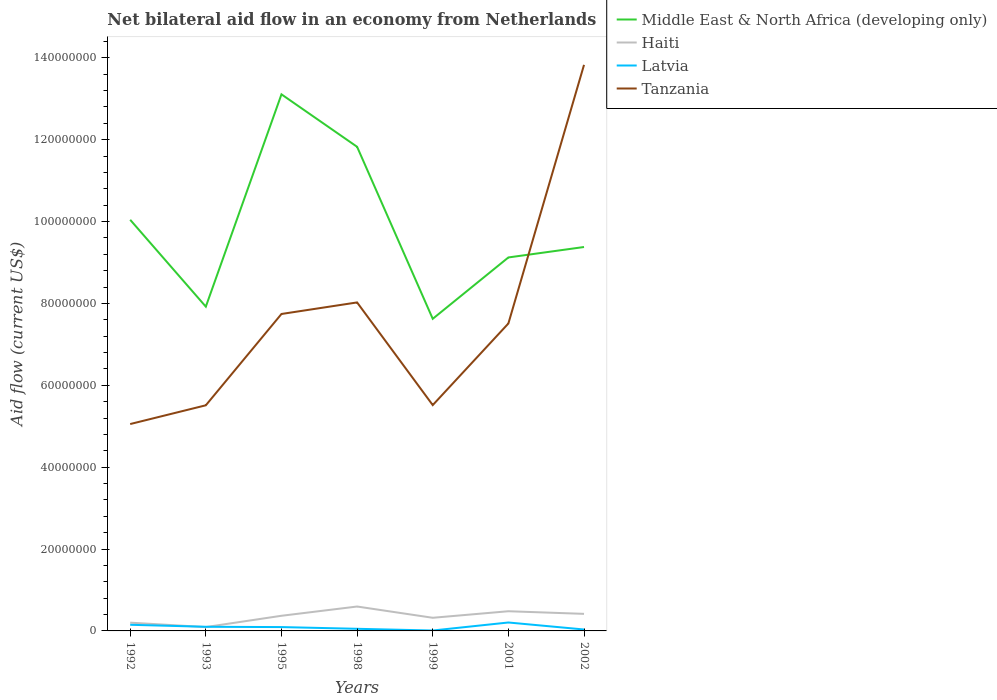How many different coloured lines are there?
Your answer should be very brief. 4. Does the line corresponding to Haiti intersect with the line corresponding to Middle East & North Africa (developing only)?
Offer a terse response. No. What is the total net bilateral aid flow in Haiti in the graph?
Provide a succinct answer. 1.08e+06. What is the difference between the highest and the second highest net bilateral aid flow in Haiti?
Keep it short and to the point. 5.02e+06. How many years are there in the graph?
Offer a very short reply. 7. Does the graph contain grids?
Your answer should be compact. No. Where does the legend appear in the graph?
Give a very brief answer. Top right. How many legend labels are there?
Offer a very short reply. 4. What is the title of the graph?
Offer a terse response. Net bilateral aid flow in an economy from Netherlands. Does "Latin America(all income levels)" appear as one of the legend labels in the graph?
Your answer should be compact. No. What is the Aid flow (current US$) of Middle East & North Africa (developing only) in 1992?
Your answer should be compact. 1.00e+08. What is the Aid flow (current US$) in Haiti in 1992?
Give a very brief answer. 2.02e+06. What is the Aid flow (current US$) in Latvia in 1992?
Keep it short and to the point. 1.50e+06. What is the Aid flow (current US$) of Tanzania in 1992?
Offer a terse response. 5.05e+07. What is the Aid flow (current US$) of Middle East & North Africa (developing only) in 1993?
Keep it short and to the point. 7.92e+07. What is the Aid flow (current US$) in Haiti in 1993?
Offer a terse response. 9.40e+05. What is the Aid flow (current US$) of Latvia in 1993?
Ensure brevity in your answer.  1.01e+06. What is the Aid flow (current US$) in Tanzania in 1993?
Make the answer very short. 5.51e+07. What is the Aid flow (current US$) of Middle East & North Africa (developing only) in 1995?
Give a very brief answer. 1.31e+08. What is the Aid flow (current US$) of Haiti in 1995?
Offer a very short reply. 3.70e+06. What is the Aid flow (current US$) of Latvia in 1995?
Offer a very short reply. 9.40e+05. What is the Aid flow (current US$) of Tanzania in 1995?
Offer a very short reply. 7.74e+07. What is the Aid flow (current US$) in Middle East & North Africa (developing only) in 1998?
Offer a very short reply. 1.18e+08. What is the Aid flow (current US$) in Haiti in 1998?
Offer a very short reply. 5.96e+06. What is the Aid flow (current US$) of Latvia in 1998?
Your answer should be very brief. 5.20e+05. What is the Aid flow (current US$) in Tanzania in 1998?
Provide a short and direct response. 8.02e+07. What is the Aid flow (current US$) in Middle East & North Africa (developing only) in 1999?
Offer a terse response. 7.62e+07. What is the Aid flow (current US$) in Haiti in 1999?
Ensure brevity in your answer.  3.21e+06. What is the Aid flow (current US$) of Tanzania in 1999?
Your response must be concise. 5.52e+07. What is the Aid flow (current US$) of Middle East & North Africa (developing only) in 2001?
Provide a succinct answer. 9.12e+07. What is the Aid flow (current US$) of Haiti in 2001?
Give a very brief answer. 4.81e+06. What is the Aid flow (current US$) of Latvia in 2001?
Your answer should be very brief. 2.06e+06. What is the Aid flow (current US$) of Tanzania in 2001?
Your answer should be compact. 7.51e+07. What is the Aid flow (current US$) of Middle East & North Africa (developing only) in 2002?
Make the answer very short. 9.38e+07. What is the Aid flow (current US$) of Haiti in 2002?
Offer a terse response. 4.17e+06. What is the Aid flow (current US$) of Latvia in 2002?
Keep it short and to the point. 3.50e+05. What is the Aid flow (current US$) of Tanzania in 2002?
Give a very brief answer. 1.38e+08. Across all years, what is the maximum Aid flow (current US$) of Middle East & North Africa (developing only)?
Your answer should be compact. 1.31e+08. Across all years, what is the maximum Aid flow (current US$) in Haiti?
Your answer should be very brief. 5.96e+06. Across all years, what is the maximum Aid flow (current US$) of Latvia?
Your answer should be compact. 2.06e+06. Across all years, what is the maximum Aid flow (current US$) of Tanzania?
Your answer should be compact. 1.38e+08. Across all years, what is the minimum Aid flow (current US$) of Middle East & North Africa (developing only)?
Ensure brevity in your answer.  7.62e+07. Across all years, what is the minimum Aid flow (current US$) in Haiti?
Your response must be concise. 9.40e+05. Across all years, what is the minimum Aid flow (current US$) in Tanzania?
Provide a short and direct response. 5.05e+07. What is the total Aid flow (current US$) in Middle East & North Africa (developing only) in the graph?
Keep it short and to the point. 6.90e+08. What is the total Aid flow (current US$) in Haiti in the graph?
Your response must be concise. 2.48e+07. What is the total Aid flow (current US$) in Latvia in the graph?
Ensure brevity in your answer.  6.48e+06. What is the total Aid flow (current US$) in Tanzania in the graph?
Offer a terse response. 5.32e+08. What is the difference between the Aid flow (current US$) of Middle East & North Africa (developing only) in 1992 and that in 1993?
Ensure brevity in your answer.  2.12e+07. What is the difference between the Aid flow (current US$) of Haiti in 1992 and that in 1993?
Provide a short and direct response. 1.08e+06. What is the difference between the Aid flow (current US$) in Tanzania in 1992 and that in 1993?
Provide a succinct answer. -4.58e+06. What is the difference between the Aid flow (current US$) in Middle East & North Africa (developing only) in 1992 and that in 1995?
Your answer should be very brief. -3.06e+07. What is the difference between the Aid flow (current US$) of Haiti in 1992 and that in 1995?
Give a very brief answer. -1.68e+06. What is the difference between the Aid flow (current US$) in Latvia in 1992 and that in 1995?
Provide a succinct answer. 5.60e+05. What is the difference between the Aid flow (current US$) in Tanzania in 1992 and that in 1995?
Your answer should be very brief. -2.69e+07. What is the difference between the Aid flow (current US$) in Middle East & North Africa (developing only) in 1992 and that in 1998?
Offer a terse response. -1.78e+07. What is the difference between the Aid flow (current US$) of Haiti in 1992 and that in 1998?
Offer a very short reply. -3.94e+06. What is the difference between the Aid flow (current US$) of Latvia in 1992 and that in 1998?
Your response must be concise. 9.80e+05. What is the difference between the Aid flow (current US$) in Tanzania in 1992 and that in 1998?
Your response must be concise. -2.97e+07. What is the difference between the Aid flow (current US$) in Middle East & North Africa (developing only) in 1992 and that in 1999?
Your answer should be compact. 2.42e+07. What is the difference between the Aid flow (current US$) of Haiti in 1992 and that in 1999?
Provide a short and direct response. -1.19e+06. What is the difference between the Aid flow (current US$) in Latvia in 1992 and that in 1999?
Provide a short and direct response. 1.40e+06. What is the difference between the Aid flow (current US$) of Tanzania in 1992 and that in 1999?
Your response must be concise. -4.63e+06. What is the difference between the Aid flow (current US$) of Middle East & North Africa (developing only) in 1992 and that in 2001?
Your answer should be compact. 9.20e+06. What is the difference between the Aid flow (current US$) in Haiti in 1992 and that in 2001?
Keep it short and to the point. -2.79e+06. What is the difference between the Aid flow (current US$) of Latvia in 1992 and that in 2001?
Keep it short and to the point. -5.60e+05. What is the difference between the Aid flow (current US$) in Tanzania in 1992 and that in 2001?
Ensure brevity in your answer.  -2.46e+07. What is the difference between the Aid flow (current US$) in Middle East & North Africa (developing only) in 1992 and that in 2002?
Give a very brief answer. 6.65e+06. What is the difference between the Aid flow (current US$) in Haiti in 1992 and that in 2002?
Give a very brief answer. -2.15e+06. What is the difference between the Aid flow (current US$) of Latvia in 1992 and that in 2002?
Make the answer very short. 1.15e+06. What is the difference between the Aid flow (current US$) in Tanzania in 1992 and that in 2002?
Give a very brief answer. -8.78e+07. What is the difference between the Aid flow (current US$) of Middle East & North Africa (developing only) in 1993 and that in 1995?
Provide a short and direct response. -5.19e+07. What is the difference between the Aid flow (current US$) in Haiti in 1993 and that in 1995?
Your response must be concise. -2.76e+06. What is the difference between the Aid flow (current US$) in Tanzania in 1993 and that in 1995?
Your answer should be compact. -2.23e+07. What is the difference between the Aid flow (current US$) of Middle East & North Africa (developing only) in 1993 and that in 1998?
Provide a short and direct response. -3.90e+07. What is the difference between the Aid flow (current US$) of Haiti in 1993 and that in 1998?
Your response must be concise. -5.02e+06. What is the difference between the Aid flow (current US$) of Tanzania in 1993 and that in 1998?
Offer a very short reply. -2.51e+07. What is the difference between the Aid flow (current US$) in Middle East & North Africa (developing only) in 1993 and that in 1999?
Make the answer very short. 2.97e+06. What is the difference between the Aid flow (current US$) in Haiti in 1993 and that in 1999?
Offer a very short reply. -2.27e+06. What is the difference between the Aid flow (current US$) of Latvia in 1993 and that in 1999?
Provide a short and direct response. 9.10e+05. What is the difference between the Aid flow (current US$) of Middle East & North Africa (developing only) in 1993 and that in 2001?
Keep it short and to the point. -1.20e+07. What is the difference between the Aid flow (current US$) of Haiti in 1993 and that in 2001?
Your answer should be very brief. -3.87e+06. What is the difference between the Aid flow (current US$) of Latvia in 1993 and that in 2001?
Give a very brief answer. -1.05e+06. What is the difference between the Aid flow (current US$) of Tanzania in 1993 and that in 2001?
Ensure brevity in your answer.  -2.00e+07. What is the difference between the Aid flow (current US$) in Middle East & North Africa (developing only) in 1993 and that in 2002?
Your response must be concise. -1.46e+07. What is the difference between the Aid flow (current US$) of Haiti in 1993 and that in 2002?
Give a very brief answer. -3.23e+06. What is the difference between the Aid flow (current US$) of Latvia in 1993 and that in 2002?
Your answer should be very brief. 6.60e+05. What is the difference between the Aid flow (current US$) in Tanzania in 1993 and that in 2002?
Offer a terse response. -8.32e+07. What is the difference between the Aid flow (current US$) in Middle East & North Africa (developing only) in 1995 and that in 1998?
Offer a very short reply. 1.28e+07. What is the difference between the Aid flow (current US$) of Haiti in 1995 and that in 1998?
Your answer should be compact. -2.26e+06. What is the difference between the Aid flow (current US$) of Tanzania in 1995 and that in 1998?
Ensure brevity in your answer.  -2.82e+06. What is the difference between the Aid flow (current US$) in Middle East & North Africa (developing only) in 1995 and that in 1999?
Ensure brevity in your answer.  5.48e+07. What is the difference between the Aid flow (current US$) of Haiti in 1995 and that in 1999?
Your answer should be compact. 4.90e+05. What is the difference between the Aid flow (current US$) of Latvia in 1995 and that in 1999?
Give a very brief answer. 8.40e+05. What is the difference between the Aid flow (current US$) of Tanzania in 1995 and that in 1999?
Provide a short and direct response. 2.23e+07. What is the difference between the Aid flow (current US$) of Middle East & North Africa (developing only) in 1995 and that in 2001?
Provide a short and direct response. 3.98e+07. What is the difference between the Aid flow (current US$) in Haiti in 1995 and that in 2001?
Give a very brief answer. -1.11e+06. What is the difference between the Aid flow (current US$) of Latvia in 1995 and that in 2001?
Your answer should be compact. -1.12e+06. What is the difference between the Aid flow (current US$) in Tanzania in 1995 and that in 2001?
Make the answer very short. 2.32e+06. What is the difference between the Aid flow (current US$) in Middle East & North Africa (developing only) in 1995 and that in 2002?
Offer a very short reply. 3.73e+07. What is the difference between the Aid flow (current US$) in Haiti in 1995 and that in 2002?
Keep it short and to the point. -4.70e+05. What is the difference between the Aid flow (current US$) in Latvia in 1995 and that in 2002?
Keep it short and to the point. 5.90e+05. What is the difference between the Aid flow (current US$) of Tanzania in 1995 and that in 2002?
Keep it short and to the point. -6.09e+07. What is the difference between the Aid flow (current US$) of Middle East & North Africa (developing only) in 1998 and that in 1999?
Give a very brief answer. 4.20e+07. What is the difference between the Aid flow (current US$) in Haiti in 1998 and that in 1999?
Ensure brevity in your answer.  2.75e+06. What is the difference between the Aid flow (current US$) of Latvia in 1998 and that in 1999?
Provide a short and direct response. 4.20e+05. What is the difference between the Aid flow (current US$) in Tanzania in 1998 and that in 1999?
Give a very brief answer. 2.51e+07. What is the difference between the Aid flow (current US$) of Middle East & North Africa (developing only) in 1998 and that in 2001?
Your answer should be compact. 2.70e+07. What is the difference between the Aid flow (current US$) of Haiti in 1998 and that in 2001?
Provide a succinct answer. 1.15e+06. What is the difference between the Aid flow (current US$) of Latvia in 1998 and that in 2001?
Offer a terse response. -1.54e+06. What is the difference between the Aid flow (current US$) of Tanzania in 1998 and that in 2001?
Provide a short and direct response. 5.14e+06. What is the difference between the Aid flow (current US$) in Middle East & North Africa (developing only) in 1998 and that in 2002?
Your answer should be very brief. 2.45e+07. What is the difference between the Aid flow (current US$) in Haiti in 1998 and that in 2002?
Offer a terse response. 1.79e+06. What is the difference between the Aid flow (current US$) of Latvia in 1998 and that in 2002?
Ensure brevity in your answer.  1.70e+05. What is the difference between the Aid flow (current US$) of Tanzania in 1998 and that in 2002?
Provide a succinct answer. -5.80e+07. What is the difference between the Aid flow (current US$) in Middle East & North Africa (developing only) in 1999 and that in 2001?
Give a very brief answer. -1.50e+07. What is the difference between the Aid flow (current US$) in Haiti in 1999 and that in 2001?
Your answer should be compact. -1.60e+06. What is the difference between the Aid flow (current US$) of Latvia in 1999 and that in 2001?
Offer a terse response. -1.96e+06. What is the difference between the Aid flow (current US$) in Tanzania in 1999 and that in 2001?
Provide a succinct answer. -1.99e+07. What is the difference between the Aid flow (current US$) of Middle East & North Africa (developing only) in 1999 and that in 2002?
Your answer should be compact. -1.75e+07. What is the difference between the Aid flow (current US$) of Haiti in 1999 and that in 2002?
Give a very brief answer. -9.60e+05. What is the difference between the Aid flow (current US$) of Latvia in 1999 and that in 2002?
Offer a very short reply. -2.50e+05. What is the difference between the Aid flow (current US$) in Tanzania in 1999 and that in 2002?
Keep it short and to the point. -8.31e+07. What is the difference between the Aid flow (current US$) of Middle East & North Africa (developing only) in 2001 and that in 2002?
Keep it short and to the point. -2.55e+06. What is the difference between the Aid flow (current US$) in Haiti in 2001 and that in 2002?
Keep it short and to the point. 6.40e+05. What is the difference between the Aid flow (current US$) in Latvia in 2001 and that in 2002?
Offer a terse response. 1.71e+06. What is the difference between the Aid flow (current US$) of Tanzania in 2001 and that in 2002?
Your answer should be very brief. -6.32e+07. What is the difference between the Aid flow (current US$) in Middle East & North Africa (developing only) in 1992 and the Aid flow (current US$) in Haiti in 1993?
Offer a very short reply. 9.95e+07. What is the difference between the Aid flow (current US$) of Middle East & North Africa (developing only) in 1992 and the Aid flow (current US$) of Latvia in 1993?
Your answer should be very brief. 9.94e+07. What is the difference between the Aid flow (current US$) of Middle East & North Africa (developing only) in 1992 and the Aid flow (current US$) of Tanzania in 1993?
Offer a terse response. 4.53e+07. What is the difference between the Aid flow (current US$) in Haiti in 1992 and the Aid flow (current US$) in Latvia in 1993?
Provide a succinct answer. 1.01e+06. What is the difference between the Aid flow (current US$) of Haiti in 1992 and the Aid flow (current US$) of Tanzania in 1993?
Keep it short and to the point. -5.31e+07. What is the difference between the Aid flow (current US$) of Latvia in 1992 and the Aid flow (current US$) of Tanzania in 1993?
Offer a very short reply. -5.36e+07. What is the difference between the Aid flow (current US$) in Middle East & North Africa (developing only) in 1992 and the Aid flow (current US$) in Haiti in 1995?
Provide a short and direct response. 9.67e+07. What is the difference between the Aid flow (current US$) in Middle East & North Africa (developing only) in 1992 and the Aid flow (current US$) in Latvia in 1995?
Your answer should be compact. 9.95e+07. What is the difference between the Aid flow (current US$) of Middle East & North Africa (developing only) in 1992 and the Aid flow (current US$) of Tanzania in 1995?
Your answer should be very brief. 2.30e+07. What is the difference between the Aid flow (current US$) in Haiti in 1992 and the Aid flow (current US$) in Latvia in 1995?
Your answer should be very brief. 1.08e+06. What is the difference between the Aid flow (current US$) of Haiti in 1992 and the Aid flow (current US$) of Tanzania in 1995?
Your response must be concise. -7.54e+07. What is the difference between the Aid flow (current US$) in Latvia in 1992 and the Aid flow (current US$) in Tanzania in 1995?
Give a very brief answer. -7.59e+07. What is the difference between the Aid flow (current US$) in Middle East & North Africa (developing only) in 1992 and the Aid flow (current US$) in Haiti in 1998?
Your answer should be compact. 9.45e+07. What is the difference between the Aid flow (current US$) in Middle East & North Africa (developing only) in 1992 and the Aid flow (current US$) in Latvia in 1998?
Your answer should be compact. 9.99e+07. What is the difference between the Aid flow (current US$) in Middle East & North Africa (developing only) in 1992 and the Aid flow (current US$) in Tanzania in 1998?
Offer a terse response. 2.02e+07. What is the difference between the Aid flow (current US$) of Haiti in 1992 and the Aid flow (current US$) of Latvia in 1998?
Keep it short and to the point. 1.50e+06. What is the difference between the Aid flow (current US$) in Haiti in 1992 and the Aid flow (current US$) in Tanzania in 1998?
Provide a succinct answer. -7.82e+07. What is the difference between the Aid flow (current US$) of Latvia in 1992 and the Aid flow (current US$) of Tanzania in 1998?
Provide a succinct answer. -7.88e+07. What is the difference between the Aid flow (current US$) of Middle East & North Africa (developing only) in 1992 and the Aid flow (current US$) of Haiti in 1999?
Provide a short and direct response. 9.72e+07. What is the difference between the Aid flow (current US$) in Middle East & North Africa (developing only) in 1992 and the Aid flow (current US$) in Latvia in 1999?
Your answer should be very brief. 1.00e+08. What is the difference between the Aid flow (current US$) in Middle East & North Africa (developing only) in 1992 and the Aid flow (current US$) in Tanzania in 1999?
Provide a short and direct response. 4.53e+07. What is the difference between the Aid flow (current US$) of Haiti in 1992 and the Aid flow (current US$) of Latvia in 1999?
Your answer should be compact. 1.92e+06. What is the difference between the Aid flow (current US$) in Haiti in 1992 and the Aid flow (current US$) in Tanzania in 1999?
Keep it short and to the point. -5.32e+07. What is the difference between the Aid flow (current US$) of Latvia in 1992 and the Aid flow (current US$) of Tanzania in 1999?
Your answer should be very brief. -5.37e+07. What is the difference between the Aid flow (current US$) of Middle East & North Africa (developing only) in 1992 and the Aid flow (current US$) of Haiti in 2001?
Give a very brief answer. 9.56e+07. What is the difference between the Aid flow (current US$) in Middle East & North Africa (developing only) in 1992 and the Aid flow (current US$) in Latvia in 2001?
Offer a very short reply. 9.84e+07. What is the difference between the Aid flow (current US$) of Middle East & North Africa (developing only) in 1992 and the Aid flow (current US$) of Tanzania in 2001?
Offer a terse response. 2.53e+07. What is the difference between the Aid flow (current US$) of Haiti in 1992 and the Aid flow (current US$) of Latvia in 2001?
Give a very brief answer. -4.00e+04. What is the difference between the Aid flow (current US$) of Haiti in 1992 and the Aid flow (current US$) of Tanzania in 2001?
Give a very brief answer. -7.31e+07. What is the difference between the Aid flow (current US$) in Latvia in 1992 and the Aid flow (current US$) in Tanzania in 2001?
Provide a succinct answer. -7.36e+07. What is the difference between the Aid flow (current US$) of Middle East & North Africa (developing only) in 1992 and the Aid flow (current US$) of Haiti in 2002?
Provide a succinct answer. 9.63e+07. What is the difference between the Aid flow (current US$) in Middle East & North Africa (developing only) in 1992 and the Aid flow (current US$) in Latvia in 2002?
Your answer should be compact. 1.00e+08. What is the difference between the Aid flow (current US$) of Middle East & North Africa (developing only) in 1992 and the Aid flow (current US$) of Tanzania in 2002?
Ensure brevity in your answer.  -3.78e+07. What is the difference between the Aid flow (current US$) in Haiti in 1992 and the Aid flow (current US$) in Latvia in 2002?
Offer a very short reply. 1.67e+06. What is the difference between the Aid flow (current US$) of Haiti in 1992 and the Aid flow (current US$) of Tanzania in 2002?
Give a very brief answer. -1.36e+08. What is the difference between the Aid flow (current US$) of Latvia in 1992 and the Aid flow (current US$) of Tanzania in 2002?
Your answer should be compact. -1.37e+08. What is the difference between the Aid flow (current US$) in Middle East & North Africa (developing only) in 1993 and the Aid flow (current US$) in Haiti in 1995?
Give a very brief answer. 7.55e+07. What is the difference between the Aid flow (current US$) in Middle East & North Africa (developing only) in 1993 and the Aid flow (current US$) in Latvia in 1995?
Offer a terse response. 7.83e+07. What is the difference between the Aid flow (current US$) in Middle East & North Africa (developing only) in 1993 and the Aid flow (current US$) in Tanzania in 1995?
Offer a terse response. 1.79e+06. What is the difference between the Aid flow (current US$) in Haiti in 1993 and the Aid flow (current US$) in Latvia in 1995?
Your response must be concise. 0. What is the difference between the Aid flow (current US$) in Haiti in 1993 and the Aid flow (current US$) in Tanzania in 1995?
Offer a terse response. -7.65e+07. What is the difference between the Aid flow (current US$) of Latvia in 1993 and the Aid flow (current US$) of Tanzania in 1995?
Your response must be concise. -7.64e+07. What is the difference between the Aid flow (current US$) of Middle East & North Africa (developing only) in 1993 and the Aid flow (current US$) of Haiti in 1998?
Provide a short and direct response. 7.33e+07. What is the difference between the Aid flow (current US$) in Middle East & North Africa (developing only) in 1993 and the Aid flow (current US$) in Latvia in 1998?
Make the answer very short. 7.87e+07. What is the difference between the Aid flow (current US$) in Middle East & North Africa (developing only) in 1993 and the Aid flow (current US$) in Tanzania in 1998?
Your answer should be very brief. -1.03e+06. What is the difference between the Aid flow (current US$) in Haiti in 1993 and the Aid flow (current US$) in Tanzania in 1998?
Give a very brief answer. -7.93e+07. What is the difference between the Aid flow (current US$) in Latvia in 1993 and the Aid flow (current US$) in Tanzania in 1998?
Give a very brief answer. -7.92e+07. What is the difference between the Aid flow (current US$) in Middle East & North Africa (developing only) in 1993 and the Aid flow (current US$) in Haiti in 1999?
Offer a very short reply. 7.60e+07. What is the difference between the Aid flow (current US$) of Middle East & North Africa (developing only) in 1993 and the Aid flow (current US$) of Latvia in 1999?
Offer a very short reply. 7.91e+07. What is the difference between the Aid flow (current US$) of Middle East & North Africa (developing only) in 1993 and the Aid flow (current US$) of Tanzania in 1999?
Offer a very short reply. 2.40e+07. What is the difference between the Aid flow (current US$) in Haiti in 1993 and the Aid flow (current US$) in Latvia in 1999?
Ensure brevity in your answer.  8.40e+05. What is the difference between the Aid flow (current US$) in Haiti in 1993 and the Aid flow (current US$) in Tanzania in 1999?
Provide a short and direct response. -5.42e+07. What is the difference between the Aid flow (current US$) in Latvia in 1993 and the Aid flow (current US$) in Tanzania in 1999?
Offer a very short reply. -5.42e+07. What is the difference between the Aid flow (current US$) of Middle East & North Africa (developing only) in 1993 and the Aid flow (current US$) of Haiti in 2001?
Provide a succinct answer. 7.44e+07. What is the difference between the Aid flow (current US$) of Middle East & North Africa (developing only) in 1993 and the Aid flow (current US$) of Latvia in 2001?
Your response must be concise. 7.72e+07. What is the difference between the Aid flow (current US$) in Middle East & North Africa (developing only) in 1993 and the Aid flow (current US$) in Tanzania in 2001?
Ensure brevity in your answer.  4.11e+06. What is the difference between the Aid flow (current US$) in Haiti in 1993 and the Aid flow (current US$) in Latvia in 2001?
Keep it short and to the point. -1.12e+06. What is the difference between the Aid flow (current US$) of Haiti in 1993 and the Aid flow (current US$) of Tanzania in 2001?
Provide a succinct answer. -7.42e+07. What is the difference between the Aid flow (current US$) of Latvia in 1993 and the Aid flow (current US$) of Tanzania in 2001?
Your answer should be very brief. -7.41e+07. What is the difference between the Aid flow (current US$) in Middle East & North Africa (developing only) in 1993 and the Aid flow (current US$) in Haiti in 2002?
Keep it short and to the point. 7.50e+07. What is the difference between the Aid flow (current US$) in Middle East & North Africa (developing only) in 1993 and the Aid flow (current US$) in Latvia in 2002?
Offer a terse response. 7.89e+07. What is the difference between the Aid flow (current US$) of Middle East & North Africa (developing only) in 1993 and the Aid flow (current US$) of Tanzania in 2002?
Your answer should be compact. -5.91e+07. What is the difference between the Aid flow (current US$) in Haiti in 1993 and the Aid flow (current US$) in Latvia in 2002?
Your response must be concise. 5.90e+05. What is the difference between the Aid flow (current US$) in Haiti in 1993 and the Aid flow (current US$) in Tanzania in 2002?
Give a very brief answer. -1.37e+08. What is the difference between the Aid flow (current US$) in Latvia in 1993 and the Aid flow (current US$) in Tanzania in 2002?
Give a very brief answer. -1.37e+08. What is the difference between the Aid flow (current US$) of Middle East & North Africa (developing only) in 1995 and the Aid flow (current US$) of Haiti in 1998?
Make the answer very short. 1.25e+08. What is the difference between the Aid flow (current US$) in Middle East & North Africa (developing only) in 1995 and the Aid flow (current US$) in Latvia in 1998?
Keep it short and to the point. 1.31e+08. What is the difference between the Aid flow (current US$) of Middle East & North Africa (developing only) in 1995 and the Aid flow (current US$) of Tanzania in 1998?
Provide a short and direct response. 5.08e+07. What is the difference between the Aid flow (current US$) of Haiti in 1995 and the Aid flow (current US$) of Latvia in 1998?
Keep it short and to the point. 3.18e+06. What is the difference between the Aid flow (current US$) in Haiti in 1995 and the Aid flow (current US$) in Tanzania in 1998?
Give a very brief answer. -7.66e+07. What is the difference between the Aid flow (current US$) of Latvia in 1995 and the Aid flow (current US$) of Tanzania in 1998?
Provide a short and direct response. -7.93e+07. What is the difference between the Aid flow (current US$) in Middle East & North Africa (developing only) in 1995 and the Aid flow (current US$) in Haiti in 1999?
Your answer should be very brief. 1.28e+08. What is the difference between the Aid flow (current US$) of Middle East & North Africa (developing only) in 1995 and the Aid flow (current US$) of Latvia in 1999?
Make the answer very short. 1.31e+08. What is the difference between the Aid flow (current US$) in Middle East & North Africa (developing only) in 1995 and the Aid flow (current US$) in Tanzania in 1999?
Ensure brevity in your answer.  7.59e+07. What is the difference between the Aid flow (current US$) in Haiti in 1995 and the Aid flow (current US$) in Latvia in 1999?
Provide a succinct answer. 3.60e+06. What is the difference between the Aid flow (current US$) of Haiti in 1995 and the Aid flow (current US$) of Tanzania in 1999?
Provide a short and direct response. -5.15e+07. What is the difference between the Aid flow (current US$) of Latvia in 1995 and the Aid flow (current US$) of Tanzania in 1999?
Your answer should be very brief. -5.42e+07. What is the difference between the Aid flow (current US$) in Middle East & North Africa (developing only) in 1995 and the Aid flow (current US$) in Haiti in 2001?
Provide a succinct answer. 1.26e+08. What is the difference between the Aid flow (current US$) of Middle East & North Africa (developing only) in 1995 and the Aid flow (current US$) of Latvia in 2001?
Provide a short and direct response. 1.29e+08. What is the difference between the Aid flow (current US$) of Middle East & North Africa (developing only) in 1995 and the Aid flow (current US$) of Tanzania in 2001?
Your response must be concise. 5.60e+07. What is the difference between the Aid flow (current US$) of Haiti in 1995 and the Aid flow (current US$) of Latvia in 2001?
Keep it short and to the point. 1.64e+06. What is the difference between the Aid flow (current US$) of Haiti in 1995 and the Aid flow (current US$) of Tanzania in 2001?
Provide a succinct answer. -7.14e+07. What is the difference between the Aid flow (current US$) of Latvia in 1995 and the Aid flow (current US$) of Tanzania in 2001?
Offer a very short reply. -7.42e+07. What is the difference between the Aid flow (current US$) of Middle East & North Africa (developing only) in 1995 and the Aid flow (current US$) of Haiti in 2002?
Provide a short and direct response. 1.27e+08. What is the difference between the Aid flow (current US$) in Middle East & North Africa (developing only) in 1995 and the Aid flow (current US$) in Latvia in 2002?
Keep it short and to the point. 1.31e+08. What is the difference between the Aid flow (current US$) of Middle East & North Africa (developing only) in 1995 and the Aid flow (current US$) of Tanzania in 2002?
Make the answer very short. -7.20e+06. What is the difference between the Aid flow (current US$) in Haiti in 1995 and the Aid flow (current US$) in Latvia in 2002?
Make the answer very short. 3.35e+06. What is the difference between the Aid flow (current US$) in Haiti in 1995 and the Aid flow (current US$) in Tanzania in 2002?
Provide a short and direct response. -1.35e+08. What is the difference between the Aid flow (current US$) in Latvia in 1995 and the Aid flow (current US$) in Tanzania in 2002?
Offer a very short reply. -1.37e+08. What is the difference between the Aid flow (current US$) of Middle East & North Africa (developing only) in 1998 and the Aid flow (current US$) of Haiti in 1999?
Offer a very short reply. 1.15e+08. What is the difference between the Aid flow (current US$) of Middle East & North Africa (developing only) in 1998 and the Aid flow (current US$) of Latvia in 1999?
Provide a short and direct response. 1.18e+08. What is the difference between the Aid flow (current US$) in Middle East & North Africa (developing only) in 1998 and the Aid flow (current US$) in Tanzania in 1999?
Your answer should be compact. 6.31e+07. What is the difference between the Aid flow (current US$) of Haiti in 1998 and the Aid flow (current US$) of Latvia in 1999?
Offer a very short reply. 5.86e+06. What is the difference between the Aid flow (current US$) of Haiti in 1998 and the Aid flow (current US$) of Tanzania in 1999?
Provide a succinct answer. -4.92e+07. What is the difference between the Aid flow (current US$) of Latvia in 1998 and the Aid flow (current US$) of Tanzania in 1999?
Your answer should be very brief. -5.46e+07. What is the difference between the Aid flow (current US$) in Middle East & North Africa (developing only) in 1998 and the Aid flow (current US$) in Haiti in 2001?
Ensure brevity in your answer.  1.13e+08. What is the difference between the Aid flow (current US$) in Middle East & North Africa (developing only) in 1998 and the Aid flow (current US$) in Latvia in 2001?
Give a very brief answer. 1.16e+08. What is the difference between the Aid flow (current US$) of Middle East & North Africa (developing only) in 1998 and the Aid flow (current US$) of Tanzania in 2001?
Keep it short and to the point. 4.32e+07. What is the difference between the Aid flow (current US$) in Haiti in 1998 and the Aid flow (current US$) in Latvia in 2001?
Ensure brevity in your answer.  3.90e+06. What is the difference between the Aid flow (current US$) in Haiti in 1998 and the Aid flow (current US$) in Tanzania in 2001?
Your answer should be compact. -6.92e+07. What is the difference between the Aid flow (current US$) in Latvia in 1998 and the Aid flow (current US$) in Tanzania in 2001?
Your answer should be very brief. -7.46e+07. What is the difference between the Aid flow (current US$) of Middle East & North Africa (developing only) in 1998 and the Aid flow (current US$) of Haiti in 2002?
Give a very brief answer. 1.14e+08. What is the difference between the Aid flow (current US$) of Middle East & North Africa (developing only) in 1998 and the Aid flow (current US$) of Latvia in 2002?
Keep it short and to the point. 1.18e+08. What is the difference between the Aid flow (current US$) of Middle East & North Africa (developing only) in 1998 and the Aid flow (current US$) of Tanzania in 2002?
Give a very brief answer. -2.00e+07. What is the difference between the Aid flow (current US$) of Haiti in 1998 and the Aid flow (current US$) of Latvia in 2002?
Provide a succinct answer. 5.61e+06. What is the difference between the Aid flow (current US$) in Haiti in 1998 and the Aid flow (current US$) in Tanzania in 2002?
Your response must be concise. -1.32e+08. What is the difference between the Aid flow (current US$) of Latvia in 1998 and the Aid flow (current US$) of Tanzania in 2002?
Make the answer very short. -1.38e+08. What is the difference between the Aid flow (current US$) of Middle East & North Africa (developing only) in 1999 and the Aid flow (current US$) of Haiti in 2001?
Give a very brief answer. 7.14e+07. What is the difference between the Aid flow (current US$) in Middle East & North Africa (developing only) in 1999 and the Aid flow (current US$) in Latvia in 2001?
Offer a terse response. 7.42e+07. What is the difference between the Aid flow (current US$) in Middle East & North Africa (developing only) in 1999 and the Aid flow (current US$) in Tanzania in 2001?
Offer a terse response. 1.14e+06. What is the difference between the Aid flow (current US$) of Haiti in 1999 and the Aid flow (current US$) of Latvia in 2001?
Your answer should be compact. 1.15e+06. What is the difference between the Aid flow (current US$) of Haiti in 1999 and the Aid flow (current US$) of Tanzania in 2001?
Give a very brief answer. -7.19e+07. What is the difference between the Aid flow (current US$) in Latvia in 1999 and the Aid flow (current US$) in Tanzania in 2001?
Your response must be concise. -7.50e+07. What is the difference between the Aid flow (current US$) of Middle East & North Africa (developing only) in 1999 and the Aid flow (current US$) of Haiti in 2002?
Your response must be concise. 7.21e+07. What is the difference between the Aid flow (current US$) of Middle East & North Africa (developing only) in 1999 and the Aid flow (current US$) of Latvia in 2002?
Offer a terse response. 7.59e+07. What is the difference between the Aid flow (current US$) in Middle East & North Africa (developing only) in 1999 and the Aid flow (current US$) in Tanzania in 2002?
Give a very brief answer. -6.20e+07. What is the difference between the Aid flow (current US$) of Haiti in 1999 and the Aid flow (current US$) of Latvia in 2002?
Your response must be concise. 2.86e+06. What is the difference between the Aid flow (current US$) in Haiti in 1999 and the Aid flow (current US$) in Tanzania in 2002?
Offer a terse response. -1.35e+08. What is the difference between the Aid flow (current US$) of Latvia in 1999 and the Aid flow (current US$) of Tanzania in 2002?
Give a very brief answer. -1.38e+08. What is the difference between the Aid flow (current US$) of Middle East & North Africa (developing only) in 2001 and the Aid flow (current US$) of Haiti in 2002?
Provide a succinct answer. 8.71e+07. What is the difference between the Aid flow (current US$) of Middle East & North Africa (developing only) in 2001 and the Aid flow (current US$) of Latvia in 2002?
Ensure brevity in your answer.  9.09e+07. What is the difference between the Aid flow (current US$) in Middle East & North Africa (developing only) in 2001 and the Aid flow (current US$) in Tanzania in 2002?
Provide a succinct answer. -4.70e+07. What is the difference between the Aid flow (current US$) of Haiti in 2001 and the Aid flow (current US$) of Latvia in 2002?
Your answer should be very brief. 4.46e+06. What is the difference between the Aid flow (current US$) of Haiti in 2001 and the Aid flow (current US$) of Tanzania in 2002?
Your response must be concise. -1.33e+08. What is the difference between the Aid flow (current US$) of Latvia in 2001 and the Aid flow (current US$) of Tanzania in 2002?
Give a very brief answer. -1.36e+08. What is the average Aid flow (current US$) of Middle East & North Africa (developing only) per year?
Ensure brevity in your answer.  9.86e+07. What is the average Aid flow (current US$) in Haiti per year?
Offer a terse response. 3.54e+06. What is the average Aid flow (current US$) in Latvia per year?
Give a very brief answer. 9.26e+05. What is the average Aid flow (current US$) in Tanzania per year?
Your answer should be very brief. 7.60e+07. In the year 1992, what is the difference between the Aid flow (current US$) in Middle East & North Africa (developing only) and Aid flow (current US$) in Haiti?
Offer a very short reply. 9.84e+07. In the year 1992, what is the difference between the Aid flow (current US$) of Middle East & North Africa (developing only) and Aid flow (current US$) of Latvia?
Provide a short and direct response. 9.89e+07. In the year 1992, what is the difference between the Aid flow (current US$) of Middle East & North Africa (developing only) and Aid flow (current US$) of Tanzania?
Make the answer very short. 4.99e+07. In the year 1992, what is the difference between the Aid flow (current US$) of Haiti and Aid flow (current US$) of Latvia?
Provide a short and direct response. 5.20e+05. In the year 1992, what is the difference between the Aid flow (current US$) in Haiti and Aid flow (current US$) in Tanzania?
Offer a very short reply. -4.85e+07. In the year 1992, what is the difference between the Aid flow (current US$) in Latvia and Aid flow (current US$) in Tanzania?
Provide a short and direct response. -4.90e+07. In the year 1993, what is the difference between the Aid flow (current US$) of Middle East & North Africa (developing only) and Aid flow (current US$) of Haiti?
Give a very brief answer. 7.83e+07. In the year 1993, what is the difference between the Aid flow (current US$) in Middle East & North Africa (developing only) and Aid flow (current US$) in Latvia?
Give a very brief answer. 7.82e+07. In the year 1993, what is the difference between the Aid flow (current US$) of Middle East & North Africa (developing only) and Aid flow (current US$) of Tanzania?
Offer a very short reply. 2.41e+07. In the year 1993, what is the difference between the Aid flow (current US$) of Haiti and Aid flow (current US$) of Tanzania?
Make the answer very short. -5.42e+07. In the year 1993, what is the difference between the Aid flow (current US$) of Latvia and Aid flow (current US$) of Tanzania?
Your answer should be very brief. -5.41e+07. In the year 1995, what is the difference between the Aid flow (current US$) in Middle East & North Africa (developing only) and Aid flow (current US$) in Haiti?
Make the answer very short. 1.27e+08. In the year 1995, what is the difference between the Aid flow (current US$) of Middle East & North Africa (developing only) and Aid flow (current US$) of Latvia?
Give a very brief answer. 1.30e+08. In the year 1995, what is the difference between the Aid flow (current US$) in Middle East & North Africa (developing only) and Aid flow (current US$) in Tanzania?
Keep it short and to the point. 5.37e+07. In the year 1995, what is the difference between the Aid flow (current US$) of Haiti and Aid flow (current US$) of Latvia?
Make the answer very short. 2.76e+06. In the year 1995, what is the difference between the Aid flow (current US$) in Haiti and Aid flow (current US$) in Tanzania?
Provide a short and direct response. -7.37e+07. In the year 1995, what is the difference between the Aid flow (current US$) of Latvia and Aid flow (current US$) of Tanzania?
Make the answer very short. -7.65e+07. In the year 1998, what is the difference between the Aid flow (current US$) of Middle East & North Africa (developing only) and Aid flow (current US$) of Haiti?
Provide a succinct answer. 1.12e+08. In the year 1998, what is the difference between the Aid flow (current US$) in Middle East & North Africa (developing only) and Aid flow (current US$) in Latvia?
Ensure brevity in your answer.  1.18e+08. In the year 1998, what is the difference between the Aid flow (current US$) in Middle East & North Africa (developing only) and Aid flow (current US$) in Tanzania?
Your answer should be compact. 3.80e+07. In the year 1998, what is the difference between the Aid flow (current US$) of Haiti and Aid flow (current US$) of Latvia?
Make the answer very short. 5.44e+06. In the year 1998, what is the difference between the Aid flow (current US$) of Haiti and Aid flow (current US$) of Tanzania?
Provide a succinct answer. -7.43e+07. In the year 1998, what is the difference between the Aid flow (current US$) of Latvia and Aid flow (current US$) of Tanzania?
Provide a short and direct response. -7.97e+07. In the year 1999, what is the difference between the Aid flow (current US$) of Middle East & North Africa (developing only) and Aid flow (current US$) of Haiti?
Provide a short and direct response. 7.30e+07. In the year 1999, what is the difference between the Aid flow (current US$) of Middle East & North Africa (developing only) and Aid flow (current US$) of Latvia?
Your answer should be compact. 7.62e+07. In the year 1999, what is the difference between the Aid flow (current US$) in Middle East & North Africa (developing only) and Aid flow (current US$) in Tanzania?
Provide a short and direct response. 2.11e+07. In the year 1999, what is the difference between the Aid flow (current US$) of Haiti and Aid flow (current US$) of Latvia?
Offer a very short reply. 3.11e+06. In the year 1999, what is the difference between the Aid flow (current US$) in Haiti and Aid flow (current US$) in Tanzania?
Offer a terse response. -5.20e+07. In the year 1999, what is the difference between the Aid flow (current US$) in Latvia and Aid flow (current US$) in Tanzania?
Offer a terse response. -5.51e+07. In the year 2001, what is the difference between the Aid flow (current US$) in Middle East & North Africa (developing only) and Aid flow (current US$) in Haiti?
Your response must be concise. 8.64e+07. In the year 2001, what is the difference between the Aid flow (current US$) in Middle East & North Africa (developing only) and Aid flow (current US$) in Latvia?
Keep it short and to the point. 8.92e+07. In the year 2001, what is the difference between the Aid flow (current US$) of Middle East & North Africa (developing only) and Aid flow (current US$) of Tanzania?
Your answer should be compact. 1.61e+07. In the year 2001, what is the difference between the Aid flow (current US$) of Haiti and Aid flow (current US$) of Latvia?
Your response must be concise. 2.75e+06. In the year 2001, what is the difference between the Aid flow (current US$) of Haiti and Aid flow (current US$) of Tanzania?
Make the answer very short. -7.03e+07. In the year 2001, what is the difference between the Aid flow (current US$) in Latvia and Aid flow (current US$) in Tanzania?
Offer a terse response. -7.30e+07. In the year 2002, what is the difference between the Aid flow (current US$) of Middle East & North Africa (developing only) and Aid flow (current US$) of Haiti?
Ensure brevity in your answer.  8.96e+07. In the year 2002, what is the difference between the Aid flow (current US$) of Middle East & North Africa (developing only) and Aid flow (current US$) of Latvia?
Ensure brevity in your answer.  9.34e+07. In the year 2002, what is the difference between the Aid flow (current US$) of Middle East & North Africa (developing only) and Aid flow (current US$) of Tanzania?
Your answer should be very brief. -4.45e+07. In the year 2002, what is the difference between the Aid flow (current US$) of Haiti and Aid flow (current US$) of Latvia?
Offer a terse response. 3.82e+06. In the year 2002, what is the difference between the Aid flow (current US$) of Haiti and Aid flow (current US$) of Tanzania?
Your response must be concise. -1.34e+08. In the year 2002, what is the difference between the Aid flow (current US$) in Latvia and Aid flow (current US$) in Tanzania?
Your answer should be very brief. -1.38e+08. What is the ratio of the Aid flow (current US$) of Middle East & North Africa (developing only) in 1992 to that in 1993?
Your answer should be compact. 1.27. What is the ratio of the Aid flow (current US$) in Haiti in 1992 to that in 1993?
Your response must be concise. 2.15. What is the ratio of the Aid flow (current US$) of Latvia in 1992 to that in 1993?
Ensure brevity in your answer.  1.49. What is the ratio of the Aid flow (current US$) in Tanzania in 1992 to that in 1993?
Your answer should be compact. 0.92. What is the ratio of the Aid flow (current US$) of Middle East & North Africa (developing only) in 1992 to that in 1995?
Provide a succinct answer. 0.77. What is the ratio of the Aid flow (current US$) of Haiti in 1992 to that in 1995?
Offer a terse response. 0.55. What is the ratio of the Aid flow (current US$) of Latvia in 1992 to that in 1995?
Offer a very short reply. 1.6. What is the ratio of the Aid flow (current US$) in Tanzania in 1992 to that in 1995?
Make the answer very short. 0.65. What is the ratio of the Aid flow (current US$) of Middle East & North Africa (developing only) in 1992 to that in 1998?
Ensure brevity in your answer.  0.85. What is the ratio of the Aid flow (current US$) of Haiti in 1992 to that in 1998?
Provide a short and direct response. 0.34. What is the ratio of the Aid flow (current US$) of Latvia in 1992 to that in 1998?
Provide a succinct answer. 2.88. What is the ratio of the Aid flow (current US$) in Tanzania in 1992 to that in 1998?
Offer a very short reply. 0.63. What is the ratio of the Aid flow (current US$) of Middle East & North Africa (developing only) in 1992 to that in 1999?
Keep it short and to the point. 1.32. What is the ratio of the Aid flow (current US$) in Haiti in 1992 to that in 1999?
Give a very brief answer. 0.63. What is the ratio of the Aid flow (current US$) in Tanzania in 1992 to that in 1999?
Provide a succinct answer. 0.92. What is the ratio of the Aid flow (current US$) of Middle East & North Africa (developing only) in 1992 to that in 2001?
Offer a terse response. 1.1. What is the ratio of the Aid flow (current US$) of Haiti in 1992 to that in 2001?
Offer a terse response. 0.42. What is the ratio of the Aid flow (current US$) in Latvia in 1992 to that in 2001?
Your answer should be compact. 0.73. What is the ratio of the Aid flow (current US$) of Tanzania in 1992 to that in 2001?
Make the answer very short. 0.67. What is the ratio of the Aid flow (current US$) of Middle East & North Africa (developing only) in 1992 to that in 2002?
Provide a succinct answer. 1.07. What is the ratio of the Aid flow (current US$) of Haiti in 1992 to that in 2002?
Provide a short and direct response. 0.48. What is the ratio of the Aid flow (current US$) in Latvia in 1992 to that in 2002?
Give a very brief answer. 4.29. What is the ratio of the Aid flow (current US$) of Tanzania in 1992 to that in 2002?
Give a very brief answer. 0.37. What is the ratio of the Aid flow (current US$) in Middle East & North Africa (developing only) in 1993 to that in 1995?
Make the answer very short. 0.6. What is the ratio of the Aid flow (current US$) in Haiti in 1993 to that in 1995?
Provide a succinct answer. 0.25. What is the ratio of the Aid flow (current US$) of Latvia in 1993 to that in 1995?
Provide a short and direct response. 1.07. What is the ratio of the Aid flow (current US$) of Tanzania in 1993 to that in 1995?
Ensure brevity in your answer.  0.71. What is the ratio of the Aid flow (current US$) of Middle East & North Africa (developing only) in 1993 to that in 1998?
Offer a terse response. 0.67. What is the ratio of the Aid flow (current US$) in Haiti in 1993 to that in 1998?
Your answer should be very brief. 0.16. What is the ratio of the Aid flow (current US$) of Latvia in 1993 to that in 1998?
Provide a short and direct response. 1.94. What is the ratio of the Aid flow (current US$) in Tanzania in 1993 to that in 1998?
Ensure brevity in your answer.  0.69. What is the ratio of the Aid flow (current US$) in Middle East & North Africa (developing only) in 1993 to that in 1999?
Provide a succinct answer. 1.04. What is the ratio of the Aid flow (current US$) in Haiti in 1993 to that in 1999?
Ensure brevity in your answer.  0.29. What is the ratio of the Aid flow (current US$) in Middle East & North Africa (developing only) in 1993 to that in 2001?
Provide a short and direct response. 0.87. What is the ratio of the Aid flow (current US$) in Haiti in 1993 to that in 2001?
Make the answer very short. 0.2. What is the ratio of the Aid flow (current US$) of Latvia in 1993 to that in 2001?
Give a very brief answer. 0.49. What is the ratio of the Aid flow (current US$) in Tanzania in 1993 to that in 2001?
Ensure brevity in your answer.  0.73. What is the ratio of the Aid flow (current US$) in Middle East & North Africa (developing only) in 1993 to that in 2002?
Your answer should be compact. 0.84. What is the ratio of the Aid flow (current US$) of Haiti in 1993 to that in 2002?
Offer a very short reply. 0.23. What is the ratio of the Aid flow (current US$) in Latvia in 1993 to that in 2002?
Offer a terse response. 2.89. What is the ratio of the Aid flow (current US$) in Tanzania in 1993 to that in 2002?
Provide a succinct answer. 0.4. What is the ratio of the Aid flow (current US$) in Middle East & North Africa (developing only) in 1995 to that in 1998?
Offer a very short reply. 1.11. What is the ratio of the Aid flow (current US$) in Haiti in 1995 to that in 1998?
Keep it short and to the point. 0.62. What is the ratio of the Aid flow (current US$) in Latvia in 1995 to that in 1998?
Give a very brief answer. 1.81. What is the ratio of the Aid flow (current US$) of Tanzania in 1995 to that in 1998?
Provide a succinct answer. 0.96. What is the ratio of the Aid flow (current US$) of Middle East & North Africa (developing only) in 1995 to that in 1999?
Offer a very short reply. 1.72. What is the ratio of the Aid flow (current US$) in Haiti in 1995 to that in 1999?
Offer a very short reply. 1.15. What is the ratio of the Aid flow (current US$) of Latvia in 1995 to that in 1999?
Provide a succinct answer. 9.4. What is the ratio of the Aid flow (current US$) of Tanzania in 1995 to that in 1999?
Ensure brevity in your answer.  1.4. What is the ratio of the Aid flow (current US$) of Middle East & North Africa (developing only) in 1995 to that in 2001?
Provide a short and direct response. 1.44. What is the ratio of the Aid flow (current US$) of Haiti in 1995 to that in 2001?
Provide a short and direct response. 0.77. What is the ratio of the Aid flow (current US$) of Latvia in 1995 to that in 2001?
Make the answer very short. 0.46. What is the ratio of the Aid flow (current US$) in Tanzania in 1995 to that in 2001?
Your answer should be very brief. 1.03. What is the ratio of the Aid flow (current US$) in Middle East & North Africa (developing only) in 1995 to that in 2002?
Give a very brief answer. 1.4. What is the ratio of the Aid flow (current US$) of Haiti in 1995 to that in 2002?
Offer a very short reply. 0.89. What is the ratio of the Aid flow (current US$) of Latvia in 1995 to that in 2002?
Provide a short and direct response. 2.69. What is the ratio of the Aid flow (current US$) of Tanzania in 1995 to that in 2002?
Your response must be concise. 0.56. What is the ratio of the Aid flow (current US$) of Middle East & North Africa (developing only) in 1998 to that in 1999?
Ensure brevity in your answer.  1.55. What is the ratio of the Aid flow (current US$) of Haiti in 1998 to that in 1999?
Provide a short and direct response. 1.86. What is the ratio of the Aid flow (current US$) of Latvia in 1998 to that in 1999?
Keep it short and to the point. 5.2. What is the ratio of the Aid flow (current US$) in Tanzania in 1998 to that in 1999?
Your response must be concise. 1.45. What is the ratio of the Aid flow (current US$) in Middle East & North Africa (developing only) in 1998 to that in 2001?
Your answer should be very brief. 1.3. What is the ratio of the Aid flow (current US$) of Haiti in 1998 to that in 2001?
Offer a terse response. 1.24. What is the ratio of the Aid flow (current US$) of Latvia in 1998 to that in 2001?
Provide a succinct answer. 0.25. What is the ratio of the Aid flow (current US$) of Tanzania in 1998 to that in 2001?
Keep it short and to the point. 1.07. What is the ratio of the Aid flow (current US$) of Middle East & North Africa (developing only) in 1998 to that in 2002?
Keep it short and to the point. 1.26. What is the ratio of the Aid flow (current US$) of Haiti in 1998 to that in 2002?
Your answer should be compact. 1.43. What is the ratio of the Aid flow (current US$) in Latvia in 1998 to that in 2002?
Offer a terse response. 1.49. What is the ratio of the Aid flow (current US$) in Tanzania in 1998 to that in 2002?
Provide a short and direct response. 0.58. What is the ratio of the Aid flow (current US$) in Middle East & North Africa (developing only) in 1999 to that in 2001?
Give a very brief answer. 0.84. What is the ratio of the Aid flow (current US$) of Haiti in 1999 to that in 2001?
Provide a succinct answer. 0.67. What is the ratio of the Aid flow (current US$) in Latvia in 1999 to that in 2001?
Your answer should be compact. 0.05. What is the ratio of the Aid flow (current US$) in Tanzania in 1999 to that in 2001?
Your answer should be compact. 0.73. What is the ratio of the Aid flow (current US$) of Middle East & North Africa (developing only) in 1999 to that in 2002?
Provide a succinct answer. 0.81. What is the ratio of the Aid flow (current US$) of Haiti in 1999 to that in 2002?
Offer a very short reply. 0.77. What is the ratio of the Aid flow (current US$) of Latvia in 1999 to that in 2002?
Your response must be concise. 0.29. What is the ratio of the Aid flow (current US$) of Tanzania in 1999 to that in 2002?
Keep it short and to the point. 0.4. What is the ratio of the Aid flow (current US$) of Middle East & North Africa (developing only) in 2001 to that in 2002?
Provide a short and direct response. 0.97. What is the ratio of the Aid flow (current US$) in Haiti in 2001 to that in 2002?
Your answer should be compact. 1.15. What is the ratio of the Aid flow (current US$) of Latvia in 2001 to that in 2002?
Provide a short and direct response. 5.89. What is the ratio of the Aid flow (current US$) in Tanzania in 2001 to that in 2002?
Your answer should be compact. 0.54. What is the difference between the highest and the second highest Aid flow (current US$) of Middle East & North Africa (developing only)?
Your response must be concise. 1.28e+07. What is the difference between the highest and the second highest Aid flow (current US$) in Haiti?
Your answer should be very brief. 1.15e+06. What is the difference between the highest and the second highest Aid flow (current US$) in Latvia?
Your answer should be compact. 5.60e+05. What is the difference between the highest and the second highest Aid flow (current US$) in Tanzania?
Ensure brevity in your answer.  5.80e+07. What is the difference between the highest and the lowest Aid flow (current US$) of Middle East & North Africa (developing only)?
Make the answer very short. 5.48e+07. What is the difference between the highest and the lowest Aid flow (current US$) in Haiti?
Your answer should be compact. 5.02e+06. What is the difference between the highest and the lowest Aid flow (current US$) in Latvia?
Ensure brevity in your answer.  1.96e+06. What is the difference between the highest and the lowest Aid flow (current US$) of Tanzania?
Provide a short and direct response. 8.78e+07. 